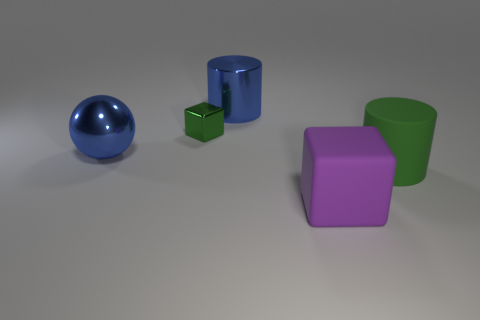Add 2 large brown blocks. How many objects exist? 7 Subtract all green cylinders. How many cylinders are left? 1 Subtract all balls. How many objects are left? 4 Subtract 1 cubes. How many cubes are left? 1 Subtract all purple cylinders. Subtract all purple spheres. How many cylinders are left? 2 Subtract all small metal objects. Subtract all tiny green rubber balls. How many objects are left? 4 Add 4 big matte blocks. How many big matte blocks are left? 5 Add 2 blue cylinders. How many blue cylinders exist? 3 Subtract 0 yellow cylinders. How many objects are left? 5 